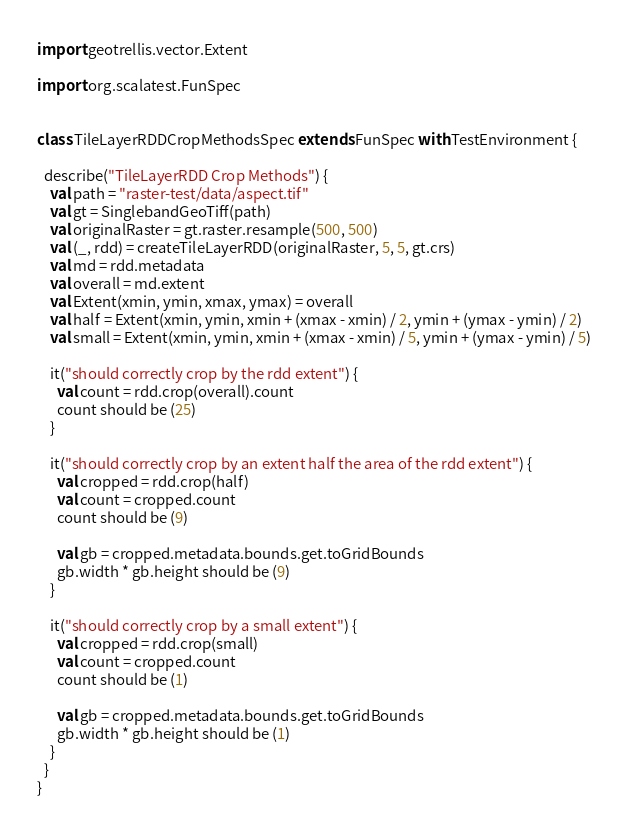<code> <loc_0><loc_0><loc_500><loc_500><_Scala_>import geotrellis.vector.Extent

import org.scalatest.FunSpec


class TileLayerRDDCropMethodsSpec extends FunSpec with TestEnvironment {

  describe("TileLayerRDD Crop Methods") {
    val path = "raster-test/data/aspect.tif"
    val gt = SinglebandGeoTiff(path)
    val originalRaster = gt.raster.resample(500, 500)
    val (_, rdd) = createTileLayerRDD(originalRaster, 5, 5, gt.crs)
    val md = rdd.metadata
    val overall = md.extent
    val Extent(xmin, ymin, xmax, ymax) = overall
    val half = Extent(xmin, ymin, xmin + (xmax - xmin) / 2, ymin + (ymax - ymin) / 2)
    val small = Extent(xmin, ymin, xmin + (xmax - xmin) / 5, ymin + (ymax - ymin) / 5)

    it("should correctly crop by the rdd extent") {
      val count = rdd.crop(overall).count
      count should be (25)
    }

    it("should correctly crop by an extent half the area of the rdd extent") {
      val cropped = rdd.crop(half)
      val count = cropped.count
      count should be (9)

      val gb = cropped.metadata.bounds.get.toGridBounds
      gb.width * gb.height should be (9)
    }

    it("should correctly crop by a small extent") {
      val cropped = rdd.crop(small)
      val count = cropped.count
      count should be (1)

      val gb = cropped.metadata.bounds.get.toGridBounds
      gb.width * gb.height should be (1)
    }
  }
}
</code> 